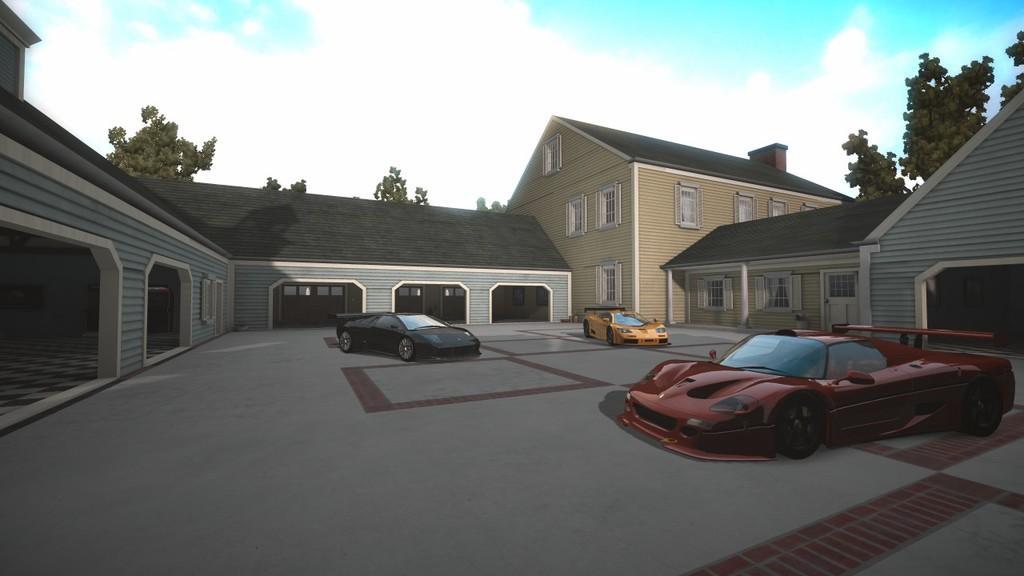Describe this image in one or two sentences. In this image we can see the animated picture of some buildings, shed, cars, windows, trees and the sky, 